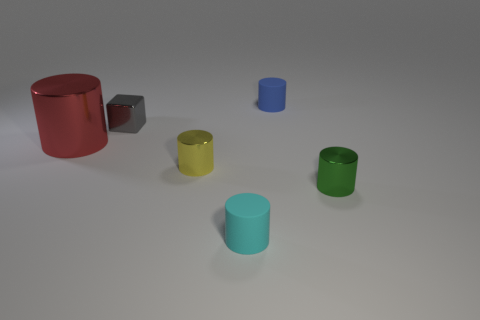Subtract all red cylinders. How many cylinders are left? 4 Add 1 small matte cylinders. How many objects exist? 7 Subtract all yellow cylinders. How many cylinders are left? 4 Subtract 3 cylinders. How many cylinders are left? 2 Add 5 cylinders. How many cylinders are left? 10 Add 1 gray metal things. How many gray metal things exist? 2 Subtract 1 red cylinders. How many objects are left? 5 Subtract all cubes. How many objects are left? 5 Subtract all yellow cylinders. Subtract all green cubes. How many cylinders are left? 4 Subtract all gray objects. Subtract all cyan spheres. How many objects are left? 5 